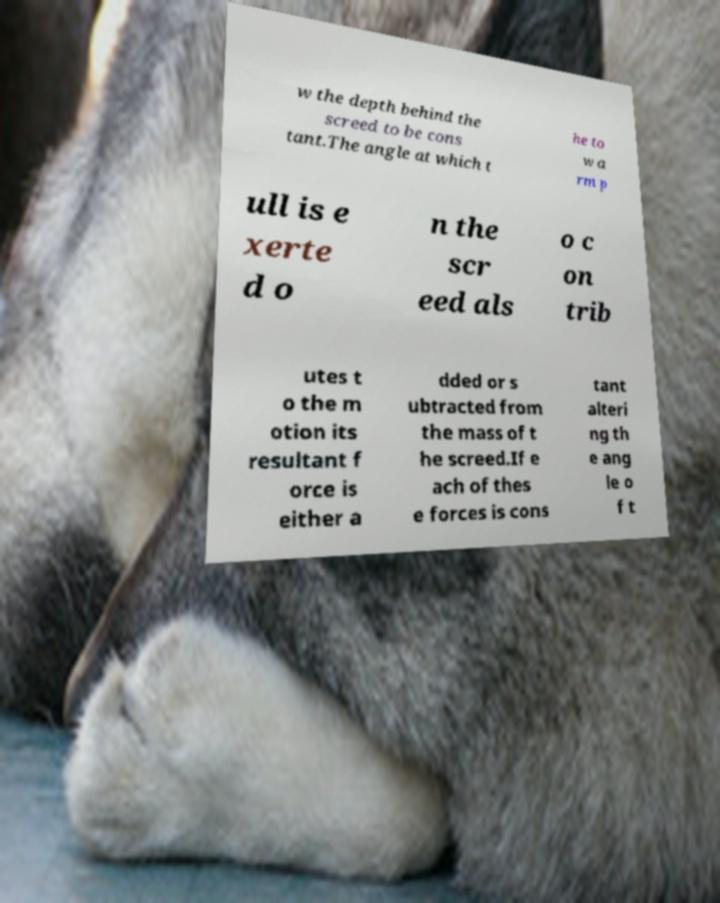Could you assist in decoding the text presented in this image and type it out clearly? w the depth behind the screed to be cons tant.The angle at which t he to w a rm p ull is e xerte d o n the scr eed als o c on trib utes t o the m otion its resultant f orce is either a dded or s ubtracted from the mass of t he screed.If e ach of thes e forces is cons tant alteri ng th e ang le o f t 